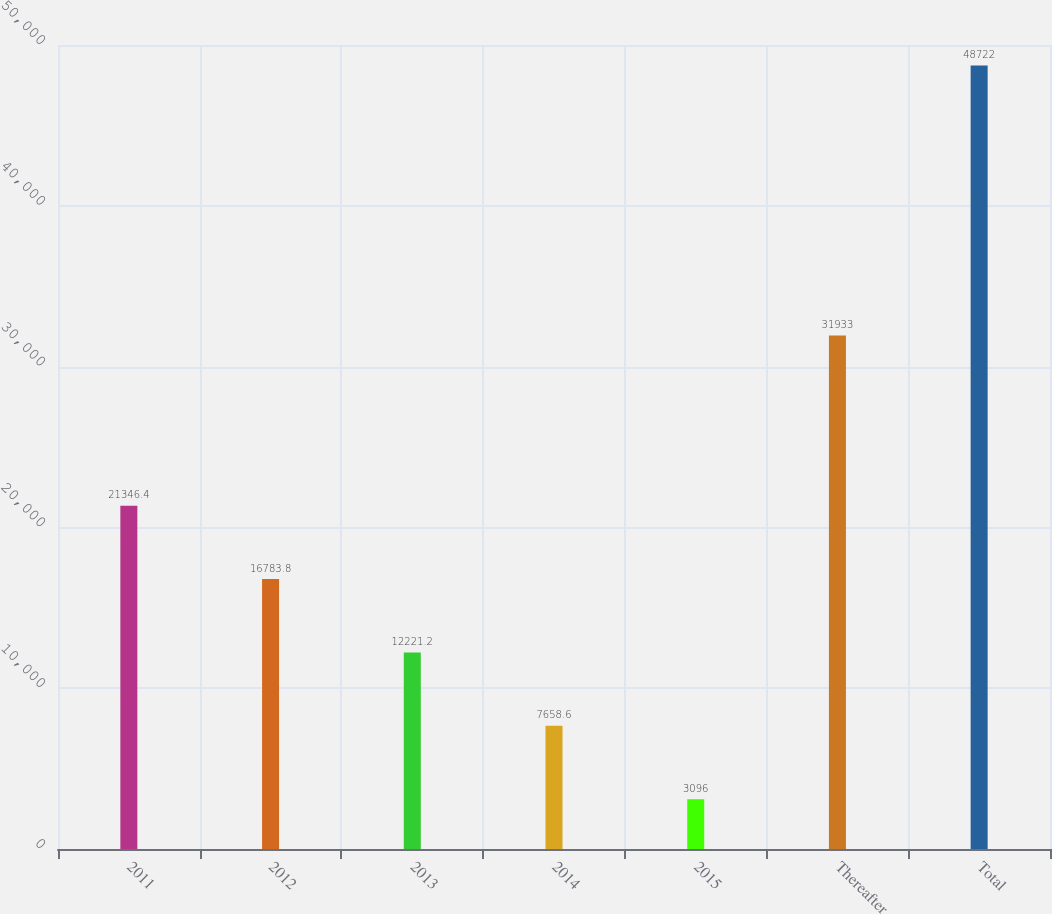Convert chart to OTSL. <chart><loc_0><loc_0><loc_500><loc_500><bar_chart><fcel>2011<fcel>2012<fcel>2013<fcel>2014<fcel>2015<fcel>Thereafter<fcel>Total<nl><fcel>21346.4<fcel>16783.8<fcel>12221.2<fcel>7658.6<fcel>3096<fcel>31933<fcel>48722<nl></chart> 